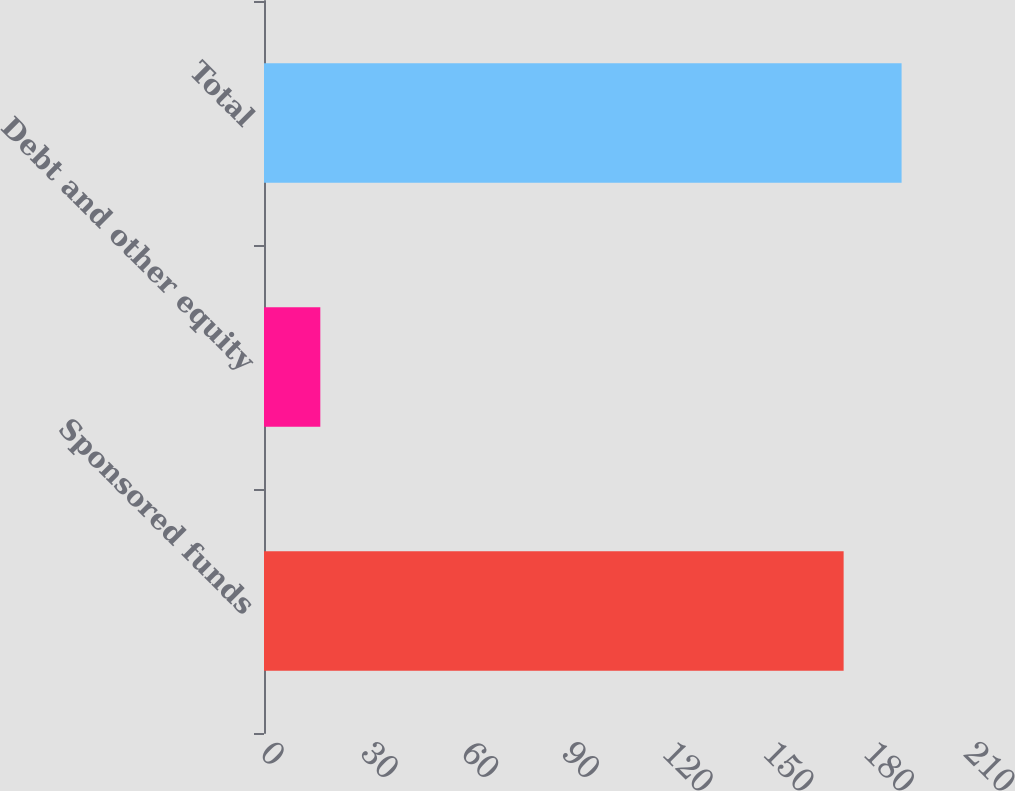Convert chart to OTSL. <chart><loc_0><loc_0><loc_500><loc_500><bar_chart><fcel>Sponsored funds<fcel>Debt and other equity<fcel>Total<nl><fcel>172.9<fcel>16.8<fcel>190.19<nl></chart> 